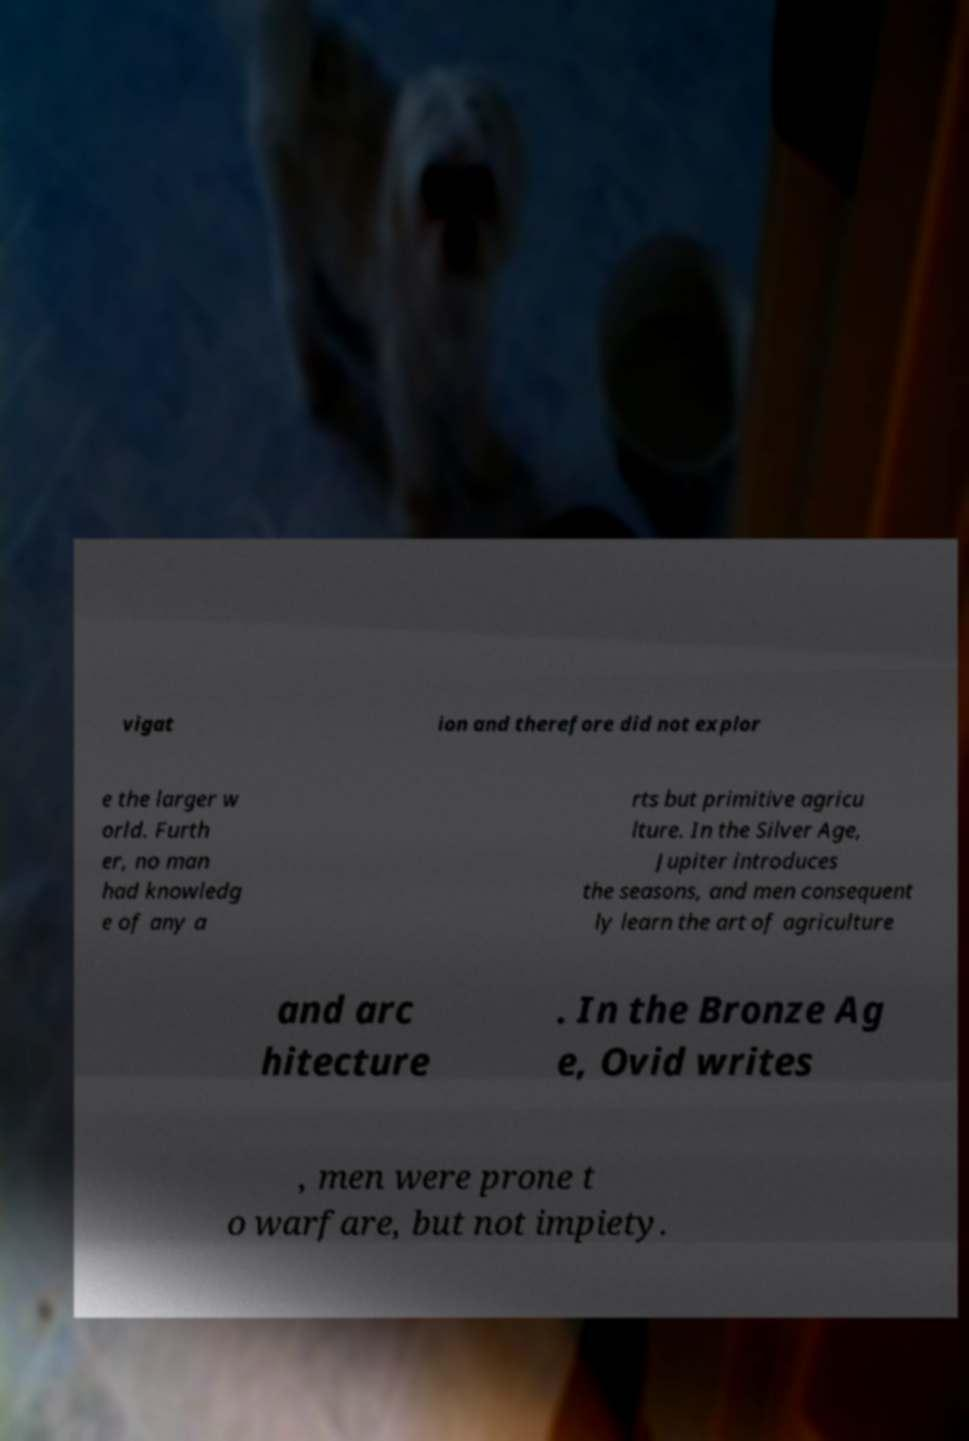I need the written content from this picture converted into text. Can you do that? vigat ion and therefore did not explor e the larger w orld. Furth er, no man had knowledg e of any a rts but primitive agricu lture. In the Silver Age, Jupiter introduces the seasons, and men consequent ly learn the art of agriculture and arc hitecture . In the Bronze Ag e, Ovid writes , men were prone t o warfare, but not impiety. 